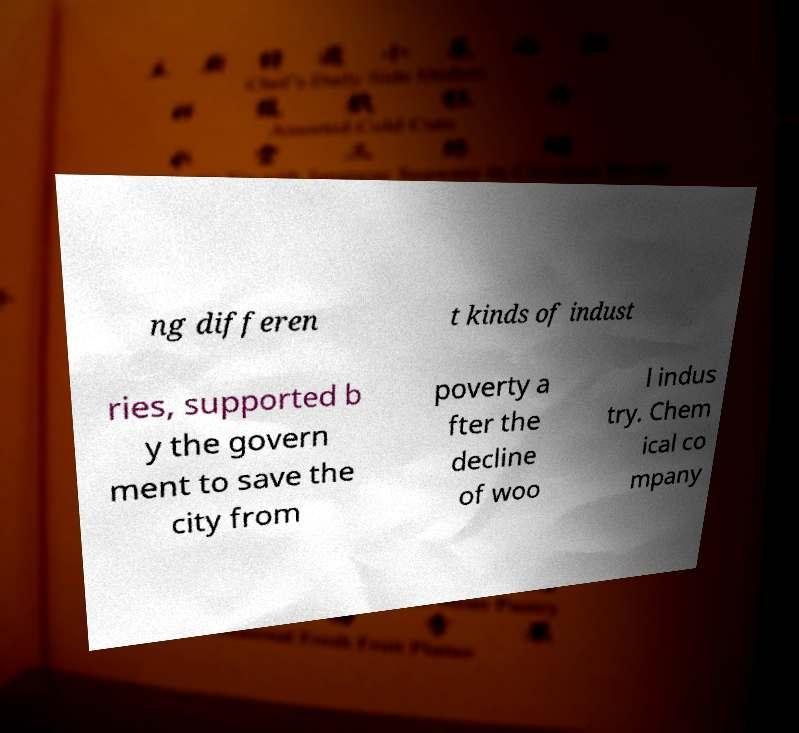I need the written content from this picture converted into text. Can you do that? ng differen t kinds of indust ries, supported b y the govern ment to save the city from poverty a fter the decline of woo l indus try. Chem ical co mpany 